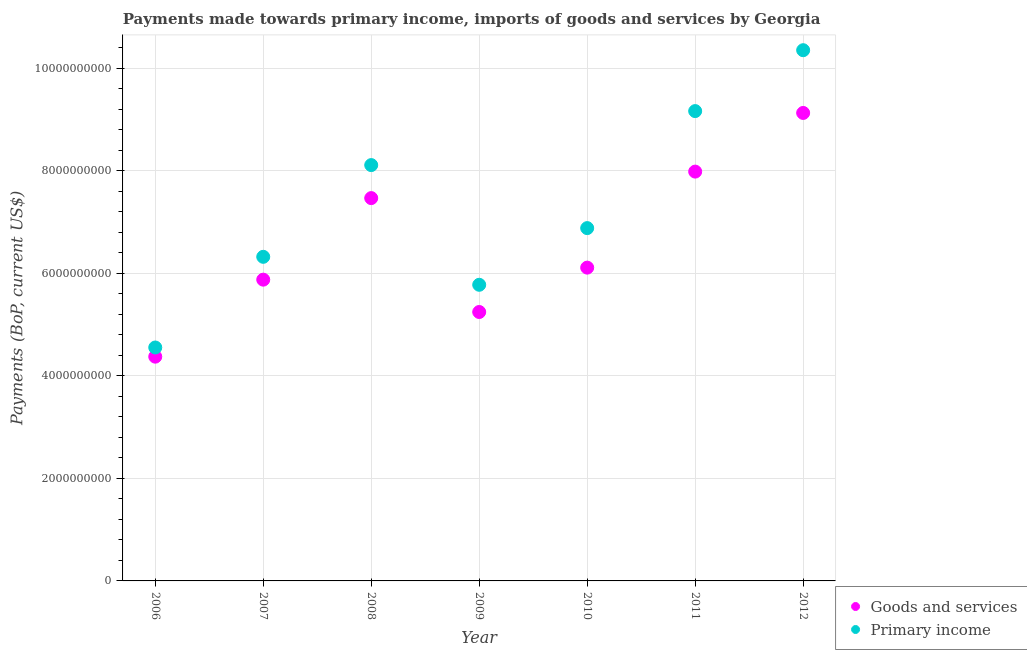Is the number of dotlines equal to the number of legend labels?
Ensure brevity in your answer.  Yes. What is the payments made towards primary income in 2011?
Your answer should be very brief. 9.17e+09. Across all years, what is the maximum payments made towards goods and services?
Provide a succinct answer. 9.13e+09. Across all years, what is the minimum payments made towards primary income?
Make the answer very short. 4.56e+09. In which year was the payments made towards primary income maximum?
Your response must be concise. 2012. What is the total payments made towards goods and services in the graph?
Keep it short and to the point. 4.62e+1. What is the difference between the payments made towards goods and services in 2007 and that in 2010?
Ensure brevity in your answer.  -2.35e+08. What is the difference between the payments made towards goods and services in 2007 and the payments made towards primary income in 2006?
Your response must be concise. 1.32e+09. What is the average payments made towards goods and services per year?
Your response must be concise. 6.60e+09. In the year 2012, what is the difference between the payments made towards goods and services and payments made towards primary income?
Offer a very short reply. -1.22e+09. What is the ratio of the payments made towards primary income in 2011 to that in 2012?
Offer a terse response. 0.89. Is the payments made towards primary income in 2008 less than that in 2012?
Provide a succinct answer. Yes. Is the difference between the payments made towards goods and services in 2007 and 2012 greater than the difference between the payments made towards primary income in 2007 and 2012?
Your answer should be compact. Yes. What is the difference between the highest and the second highest payments made towards goods and services?
Your answer should be compact. 1.14e+09. What is the difference between the highest and the lowest payments made towards goods and services?
Your answer should be compact. 4.76e+09. In how many years, is the payments made towards primary income greater than the average payments made towards primary income taken over all years?
Make the answer very short. 3. Does the payments made towards primary income monotonically increase over the years?
Ensure brevity in your answer.  No. How many dotlines are there?
Your answer should be compact. 2. How many legend labels are there?
Provide a short and direct response. 2. How are the legend labels stacked?
Give a very brief answer. Vertical. What is the title of the graph?
Your response must be concise. Payments made towards primary income, imports of goods and services by Georgia. Does "Travel services" appear as one of the legend labels in the graph?
Your response must be concise. No. What is the label or title of the X-axis?
Your answer should be compact. Year. What is the label or title of the Y-axis?
Your response must be concise. Payments (BoP, current US$). What is the Payments (BoP, current US$) of Goods and services in 2006?
Your answer should be compact. 4.38e+09. What is the Payments (BoP, current US$) in Primary income in 2006?
Keep it short and to the point. 4.56e+09. What is the Payments (BoP, current US$) of Goods and services in 2007?
Make the answer very short. 5.88e+09. What is the Payments (BoP, current US$) in Primary income in 2007?
Ensure brevity in your answer.  6.32e+09. What is the Payments (BoP, current US$) of Goods and services in 2008?
Ensure brevity in your answer.  7.47e+09. What is the Payments (BoP, current US$) in Primary income in 2008?
Give a very brief answer. 8.11e+09. What is the Payments (BoP, current US$) in Goods and services in 2009?
Offer a very short reply. 5.25e+09. What is the Payments (BoP, current US$) in Primary income in 2009?
Ensure brevity in your answer.  5.78e+09. What is the Payments (BoP, current US$) of Goods and services in 2010?
Give a very brief answer. 6.11e+09. What is the Payments (BoP, current US$) of Primary income in 2010?
Your response must be concise. 6.89e+09. What is the Payments (BoP, current US$) of Goods and services in 2011?
Make the answer very short. 7.99e+09. What is the Payments (BoP, current US$) in Primary income in 2011?
Make the answer very short. 9.17e+09. What is the Payments (BoP, current US$) of Goods and services in 2012?
Your answer should be compact. 9.13e+09. What is the Payments (BoP, current US$) of Primary income in 2012?
Your response must be concise. 1.04e+1. Across all years, what is the maximum Payments (BoP, current US$) of Goods and services?
Your answer should be very brief. 9.13e+09. Across all years, what is the maximum Payments (BoP, current US$) in Primary income?
Your response must be concise. 1.04e+1. Across all years, what is the minimum Payments (BoP, current US$) of Goods and services?
Your answer should be very brief. 4.38e+09. Across all years, what is the minimum Payments (BoP, current US$) in Primary income?
Your answer should be compact. 4.56e+09. What is the total Payments (BoP, current US$) of Goods and services in the graph?
Offer a terse response. 4.62e+1. What is the total Payments (BoP, current US$) of Primary income in the graph?
Provide a short and direct response. 5.12e+1. What is the difference between the Payments (BoP, current US$) in Goods and services in 2006 and that in 2007?
Provide a succinct answer. -1.50e+09. What is the difference between the Payments (BoP, current US$) of Primary income in 2006 and that in 2007?
Offer a very short reply. -1.77e+09. What is the difference between the Payments (BoP, current US$) in Goods and services in 2006 and that in 2008?
Your response must be concise. -3.09e+09. What is the difference between the Payments (BoP, current US$) of Primary income in 2006 and that in 2008?
Provide a short and direct response. -3.56e+09. What is the difference between the Payments (BoP, current US$) in Goods and services in 2006 and that in 2009?
Your response must be concise. -8.72e+08. What is the difference between the Payments (BoP, current US$) of Primary income in 2006 and that in 2009?
Your response must be concise. -1.22e+09. What is the difference between the Payments (BoP, current US$) of Goods and services in 2006 and that in 2010?
Your response must be concise. -1.74e+09. What is the difference between the Payments (BoP, current US$) of Primary income in 2006 and that in 2010?
Your response must be concise. -2.33e+09. What is the difference between the Payments (BoP, current US$) of Goods and services in 2006 and that in 2011?
Provide a succinct answer. -3.61e+09. What is the difference between the Payments (BoP, current US$) of Primary income in 2006 and that in 2011?
Ensure brevity in your answer.  -4.61e+09. What is the difference between the Payments (BoP, current US$) of Goods and services in 2006 and that in 2012?
Ensure brevity in your answer.  -4.76e+09. What is the difference between the Payments (BoP, current US$) of Primary income in 2006 and that in 2012?
Provide a short and direct response. -5.80e+09. What is the difference between the Payments (BoP, current US$) of Goods and services in 2007 and that in 2008?
Your response must be concise. -1.59e+09. What is the difference between the Payments (BoP, current US$) in Primary income in 2007 and that in 2008?
Provide a succinct answer. -1.79e+09. What is the difference between the Payments (BoP, current US$) in Goods and services in 2007 and that in 2009?
Give a very brief answer. 6.31e+08. What is the difference between the Payments (BoP, current US$) of Primary income in 2007 and that in 2009?
Give a very brief answer. 5.46e+08. What is the difference between the Payments (BoP, current US$) of Goods and services in 2007 and that in 2010?
Your response must be concise. -2.35e+08. What is the difference between the Payments (BoP, current US$) of Primary income in 2007 and that in 2010?
Your answer should be compact. -5.60e+08. What is the difference between the Payments (BoP, current US$) in Goods and services in 2007 and that in 2011?
Make the answer very short. -2.11e+09. What is the difference between the Payments (BoP, current US$) in Primary income in 2007 and that in 2011?
Offer a very short reply. -2.84e+09. What is the difference between the Payments (BoP, current US$) of Goods and services in 2007 and that in 2012?
Keep it short and to the point. -3.25e+09. What is the difference between the Payments (BoP, current US$) in Primary income in 2007 and that in 2012?
Make the answer very short. -4.03e+09. What is the difference between the Payments (BoP, current US$) of Goods and services in 2008 and that in 2009?
Your response must be concise. 2.22e+09. What is the difference between the Payments (BoP, current US$) in Primary income in 2008 and that in 2009?
Make the answer very short. 2.34e+09. What is the difference between the Payments (BoP, current US$) in Goods and services in 2008 and that in 2010?
Give a very brief answer. 1.36e+09. What is the difference between the Payments (BoP, current US$) of Primary income in 2008 and that in 2010?
Keep it short and to the point. 1.23e+09. What is the difference between the Payments (BoP, current US$) of Goods and services in 2008 and that in 2011?
Your response must be concise. -5.17e+08. What is the difference between the Payments (BoP, current US$) in Primary income in 2008 and that in 2011?
Make the answer very short. -1.05e+09. What is the difference between the Payments (BoP, current US$) of Goods and services in 2008 and that in 2012?
Ensure brevity in your answer.  -1.66e+09. What is the difference between the Payments (BoP, current US$) in Primary income in 2008 and that in 2012?
Provide a succinct answer. -2.24e+09. What is the difference between the Payments (BoP, current US$) of Goods and services in 2009 and that in 2010?
Keep it short and to the point. -8.66e+08. What is the difference between the Payments (BoP, current US$) of Primary income in 2009 and that in 2010?
Ensure brevity in your answer.  -1.11e+09. What is the difference between the Payments (BoP, current US$) in Goods and services in 2009 and that in 2011?
Provide a short and direct response. -2.74e+09. What is the difference between the Payments (BoP, current US$) of Primary income in 2009 and that in 2011?
Provide a succinct answer. -3.39e+09. What is the difference between the Payments (BoP, current US$) in Goods and services in 2009 and that in 2012?
Make the answer very short. -3.88e+09. What is the difference between the Payments (BoP, current US$) in Primary income in 2009 and that in 2012?
Provide a succinct answer. -4.58e+09. What is the difference between the Payments (BoP, current US$) in Goods and services in 2010 and that in 2011?
Provide a succinct answer. -1.87e+09. What is the difference between the Payments (BoP, current US$) of Primary income in 2010 and that in 2011?
Offer a very short reply. -2.28e+09. What is the difference between the Payments (BoP, current US$) in Goods and services in 2010 and that in 2012?
Provide a short and direct response. -3.02e+09. What is the difference between the Payments (BoP, current US$) in Primary income in 2010 and that in 2012?
Ensure brevity in your answer.  -3.47e+09. What is the difference between the Payments (BoP, current US$) of Goods and services in 2011 and that in 2012?
Keep it short and to the point. -1.14e+09. What is the difference between the Payments (BoP, current US$) in Primary income in 2011 and that in 2012?
Offer a terse response. -1.19e+09. What is the difference between the Payments (BoP, current US$) in Goods and services in 2006 and the Payments (BoP, current US$) in Primary income in 2007?
Give a very brief answer. -1.95e+09. What is the difference between the Payments (BoP, current US$) of Goods and services in 2006 and the Payments (BoP, current US$) of Primary income in 2008?
Provide a succinct answer. -3.74e+09. What is the difference between the Payments (BoP, current US$) of Goods and services in 2006 and the Payments (BoP, current US$) of Primary income in 2009?
Provide a short and direct response. -1.40e+09. What is the difference between the Payments (BoP, current US$) in Goods and services in 2006 and the Payments (BoP, current US$) in Primary income in 2010?
Provide a succinct answer. -2.51e+09. What is the difference between the Payments (BoP, current US$) of Goods and services in 2006 and the Payments (BoP, current US$) of Primary income in 2011?
Ensure brevity in your answer.  -4.79e+09. What is the difference between the Payments (BoP, current US$) of Goods and services in 2006 and the Payments (BoP, current US$) of Primary income in 2012?
Keep it short and to the point. -5.98e+09. What is the difference between the Payments (BoP, current US$) in Goods and services in 2007 and the Payments (BoP, current US$) in Primary income in 2008?
Keep it short and to the point. -2.24e+09. What is the difference between the Payments (BoP, current US$) of Goods and services in 2007 and the Payments (BoP, current US$) of Primary income in 2009?
Give a very brief answer. 1.00e+08. What is the difference between the Payments (BoP, current US$) in Goods and services in 2007 and the Payments (BoP, current US$) in Primary income in 2010?
Your answer should be compact. -1.01e+09. What is the difference between the Payments (BoP, current US$) in Goods and services in 2007 and the Payments (BoP, current US$) in Primary income in 2011?
Keep it short and to the point. -3.29e+09. What is the difference between the Payments (BoP, current US$) in Goods and services in 2007 and the Payments (BoP, current US$) in Primary income in 2012?
Keep it short and to the point. -4.48e+09. What is the difference between the Payments (BoP, current US$) in Goods and services in 2008 and the Payments (BoP, current US$) in Primary income in 2009?
Your answer should be very brief. 1.69e+09. What is the difference between the Payments (BoP, current US$) in Goods and services in 2008 and the Payments (BoP, current US$) in Primary income in 2010?
Offer a very short reply. 5.86e+08. What is the difference between the Payments (BoP, current US$) in Goods and services in 2008 and the Payments (BoP, current US$) in Primary income in 2011?
Keep it short and to the point. -1.70e+09. What is the difference between the Payments (BoP, current US$) in Goods and services in 2008 and the Payments (BoP, current US$) in Primary income in 2012?
Your answer should be very brief. -2.89e+09. What is the difference between the Payments (BoP, current US$) of Goods and services in 2009 and the Payments (BoP, current US$) of Primary income in 2010?
Your answer should be compact. -1.64e+09. What is the difference between the Payments (BoP, current US$) in Goods and services in 2009 and the Payments (BoP, current US$) in Primary income in 2011?
Ensure brevity in your answer.  -3.92e+09. What is the difference between the Payments (BoP, current US$) in Goods and services in 2009 and the Payments (BoP, current US$) in Primary income in 2012?
Give a very brief answer. -5.11e+09. What is the difference between the Payments (BoP, current US$) of Goods and services in 2010 and the Payments (BoP, current US$) of Primary income in 2011?
Offer a very short reply. -3.05e+09. What is the difference between the Payments (BoP, current US$) in Goods and services in 2010 and the Payments (BoP, current US$) in Primary income in 2012?
Your answer should be compact. -4.24e+09. What is the difference between the Payments (BoP, current US$) in Goods and services in 2011 and the Payments (BoP, current US$) in Primary income in 2012?
Keep it short and to the point. -2.37e+09. What is the average Payments (BoP, current US$) in Goods and services per year?
Provide a short and direct response. 6.60e+09. What is the average Payments (BoP, current US$) of Primary income per year?
Offer a very short reply. 7.31e+09. In the year 2006, what is the difference between the Payments (BoP, current US$) in Goods and services and Payments (BoP, current US$) in Primary income?
Make the answer very short. -1.79e+08. In the year 2007, what is the difference between the Payments (BoP, current US$) of Goods and services and Payments (BoP, current US$) of Primary income?
Provide a short and direct response. -4.46e+08. In the year 2008, what is the difference between the Payments (BoP, current US$) of Goods and services and Payments (BoP, current US$) of Primary income?
Keep it short and to the point. -6.44e+08. In the year 2009, what is the difference between the Payments (BoP, current US$) in Goods and services and Payments (BoP, current US$) in Primary income?
Ensure brevity in your answer.  -5.31e+08. In the year 2010, what is the difference between the Payments (BoP, current US$) in Goods and services and Payments (BoP, current US$) in Primary income?
Your answer should be very brief. -7.71e+08. In the year 2011, what is the difference between the Payments (BoP, current US$) in Goods and services and Payments (BoP, current US$) in Primary income?
Keep it short and to the point. -1.18e+09. In the year 2012, what is the difference between the Payments (BoP, current US$) in Goods and services and Payments (BoP, current US$) in Primary income?
Offer a terse response. -1.22e+09. What is the ratio of the Payments (BoP, current US$) of Goods and services in 2006 to that in 2007?
Make the answer very short. 0.74. What is the ratio of the Payments (BoP, current US$) in Primary income in 2006 to that in 2007?
Keep it short and to the point. 0.72. What is the ratio of the Payments (BoP, current US$) in Goods and services in 2006 to that in 2008?
Your answer should be compact. 0.59. What is the ratio of the Payments (BoP, current US$) of Primary income in 2006 to that in 2008?
Make the answer very short. 0.56. What is the ratio of the Payments (BoP, current US$) in Goods and services in 2006 to that in 2009?
Offer a very short reply. 0.83. What is the ratio of the Payments (BoP, current US$) in Primary income in 2006 to that in 2009?
Ensure brevity in your answer.  0.79. What is the ratio of the Payments (BoP, current US$) in Goods and services in 2006 to that in 2010?
Provide a succinct answer. 0.72. What is the ratio of the Payments (BoP, current US$) of Primary income in 2006 to that in 2010?
Give a very brief answer. 0.66. What is the ratio of the Payments (BoP, current US$) of Goods and services in 2006 to that in 2011?
Your answer should be very brief. 0.55. What is the ratio of the Payments (BoP, current US$) in Primary income in 2006 to that in 2011?
Offer a terse response. 0.5. What is the ratio of the Payments (BoP, current US$) in Goods and services in 2006 to that in 2012?
Offer a very short reply. 0.48. What is the ratio of the Payments (BoP, current US$) of Primary income in 2006 to that in 2012?
Provide a short and direct response. 0.44. What is the ratio of the Payments (BoP, current US$) in Goods and services in 2007 to that in 2008?
Ensure brevity in your answer.  0.79. What is the ratio of the Payments (BoP, current US$) of Primary income in 2007 to that in 2008?
Provide a succinct answer. 0.78. What is the ratio of the Payments (BoP, current US$) in Goods and services in 2007 to that in 2009?
Your answer should be compact. 1.12. What is the ratio of the Payments (BoP, current US$) in Primary income in 2007 to that in 2009?
Offer a very short reply. 1.09. What is the ratio of the Payments (BoP, current US$) in Goods and services in 2007 to that in 2010?
Give a very brief answer. 0.96. What is the ratio of the Payments (BoP, current US$) of Primary income in 2007 to that in 2010?
Offer a very short reply. 0.92. What is the ratio of the Payments (BoP, current US$) of Goods and services in 2007 to that in 2011?
Your answer should be compact. 0.74. What is the ratio of the Payments (BoP, current US$) in Primary income in 2007 to that in 2011?
Provide a succinct answer. 0.69. What is the ratio of the Payments (BoP, current US$) in Goods and services in 2007 to that in 2012?
Offer a very short reply. 0.64. What is the ratio of the Payments (BoP, current US$) in Primary income in 2007 to that in 2012?
Give a very brief answer. 0.61. What is the ratio of the Payments (BoP, current US$) of Goods and services in 2008 to that in 2009?
Your answer should be very brief. 1.42. What is the ratio of the Payments (BoP, current US$) of Primary income in 2008 to that in 2009?
Your answer should be very brief. 1.4. What is the ratio of the Payments (BoP, current US$) in Goods and services in 2008 to that in 2010?
Provide a succinct answer. 1.22. What is the ratio of the Payments (BoP, current US$) of Primary income in 2008 to that in 2010?
Give a very brief answer. 1.18. What is the ratio of the Payments (BoP, current US$) in Goods and services in 2008 to that in 2011?
Ensure brevity in your answer.  0.94. What is the ratio of the Payments (BoP, current US$) in Primary income in 2008 to that in 2011?
Your response must be concise. 0.89. What is the ratio of the Payments (BoP, current US$) in Goods and services in 2008 to that in 2012?
Provide a succinct answer. 0.82. What is the ratio of the Payments (BoP, current US$) in Primary income in 2008 to that in 2012?
Offer a terse response. 0.78. What is the ratio of the Payments (BoP, current US$) in Goods and services in 2009 to that in 2010?
Your response must be concise. 0.86. What is the ratio of the Payments (BoP, current US$) in Primary income in 2009 to that in 2010?
Provide a short and direct response. 0.84. What is the ratio of the Payments (BoP, current US$) in Goods and services in 2009 to that in 2011?
Offer a very short reply. 0.66. What is the ratio of the Payments (BoP, current US$) of Primary income in 2009 to that in 2011?
Provide a succinct answer. 0.63. What is the ratio of the Payments (BoP, current US$) in Goods and services in 2009 to that in 2012?
Provide a short and direct response. 0.57. What is the ratio of the Payments (BoP, current US$) of Primary income in 2009 to that in 2012?
Your response must be concise. 0.56. What is the ratio of the Payments (BoP, current US$) of Goods and services in 2010 to that in 2011?
Keep it short and to the point. 0.77. What is the ratio of the Payments (BoP, current US$) in Primary income in 2010 to that in 2011?
Give a very brief answer. 0.75. What is the ratio of the Payments (BoP, current US$) in Goods and services in 2010 to that in 2012?
Make the answer very short. 0.67. What is the ratio of the Payments (BoP, current US$) of Primary income in 2010 to that in 2012?
Your response must be concise. 0.66. What is the ratio of the Payments (BoP, current US$) of Goods and services in 2011 to that in 2012?
Offer a terse response. 0.87. What is the ratio of the Payments (BoP, current US$) in Primary income in 2011 to that in 2012?
Give a very brief answer. 0.89. What is the difference between the highest and the second highest Payments (BoP, current US$) in Goods and services?
Provide a short and direct response. 1.14e+09. What is the difference between the highest and the second highest Payments (BoP, current US$) of Primary income?
Your answer should be very brief. 1.19e+09. What is the difference between the highest and the lowest Payments (BoP, current US$) in Goods and services?
Your response must be concise. 4.76e+09. What is the difference between the highest and the lowest Payments (BoP, current US$) in Primary income?
Offer a very short reply. 5.80e+09. 